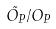<formula> <loc_0><loc_0><loc_500><loc_500>\tilde { O _ { P } } / O _ { P }</formula> 